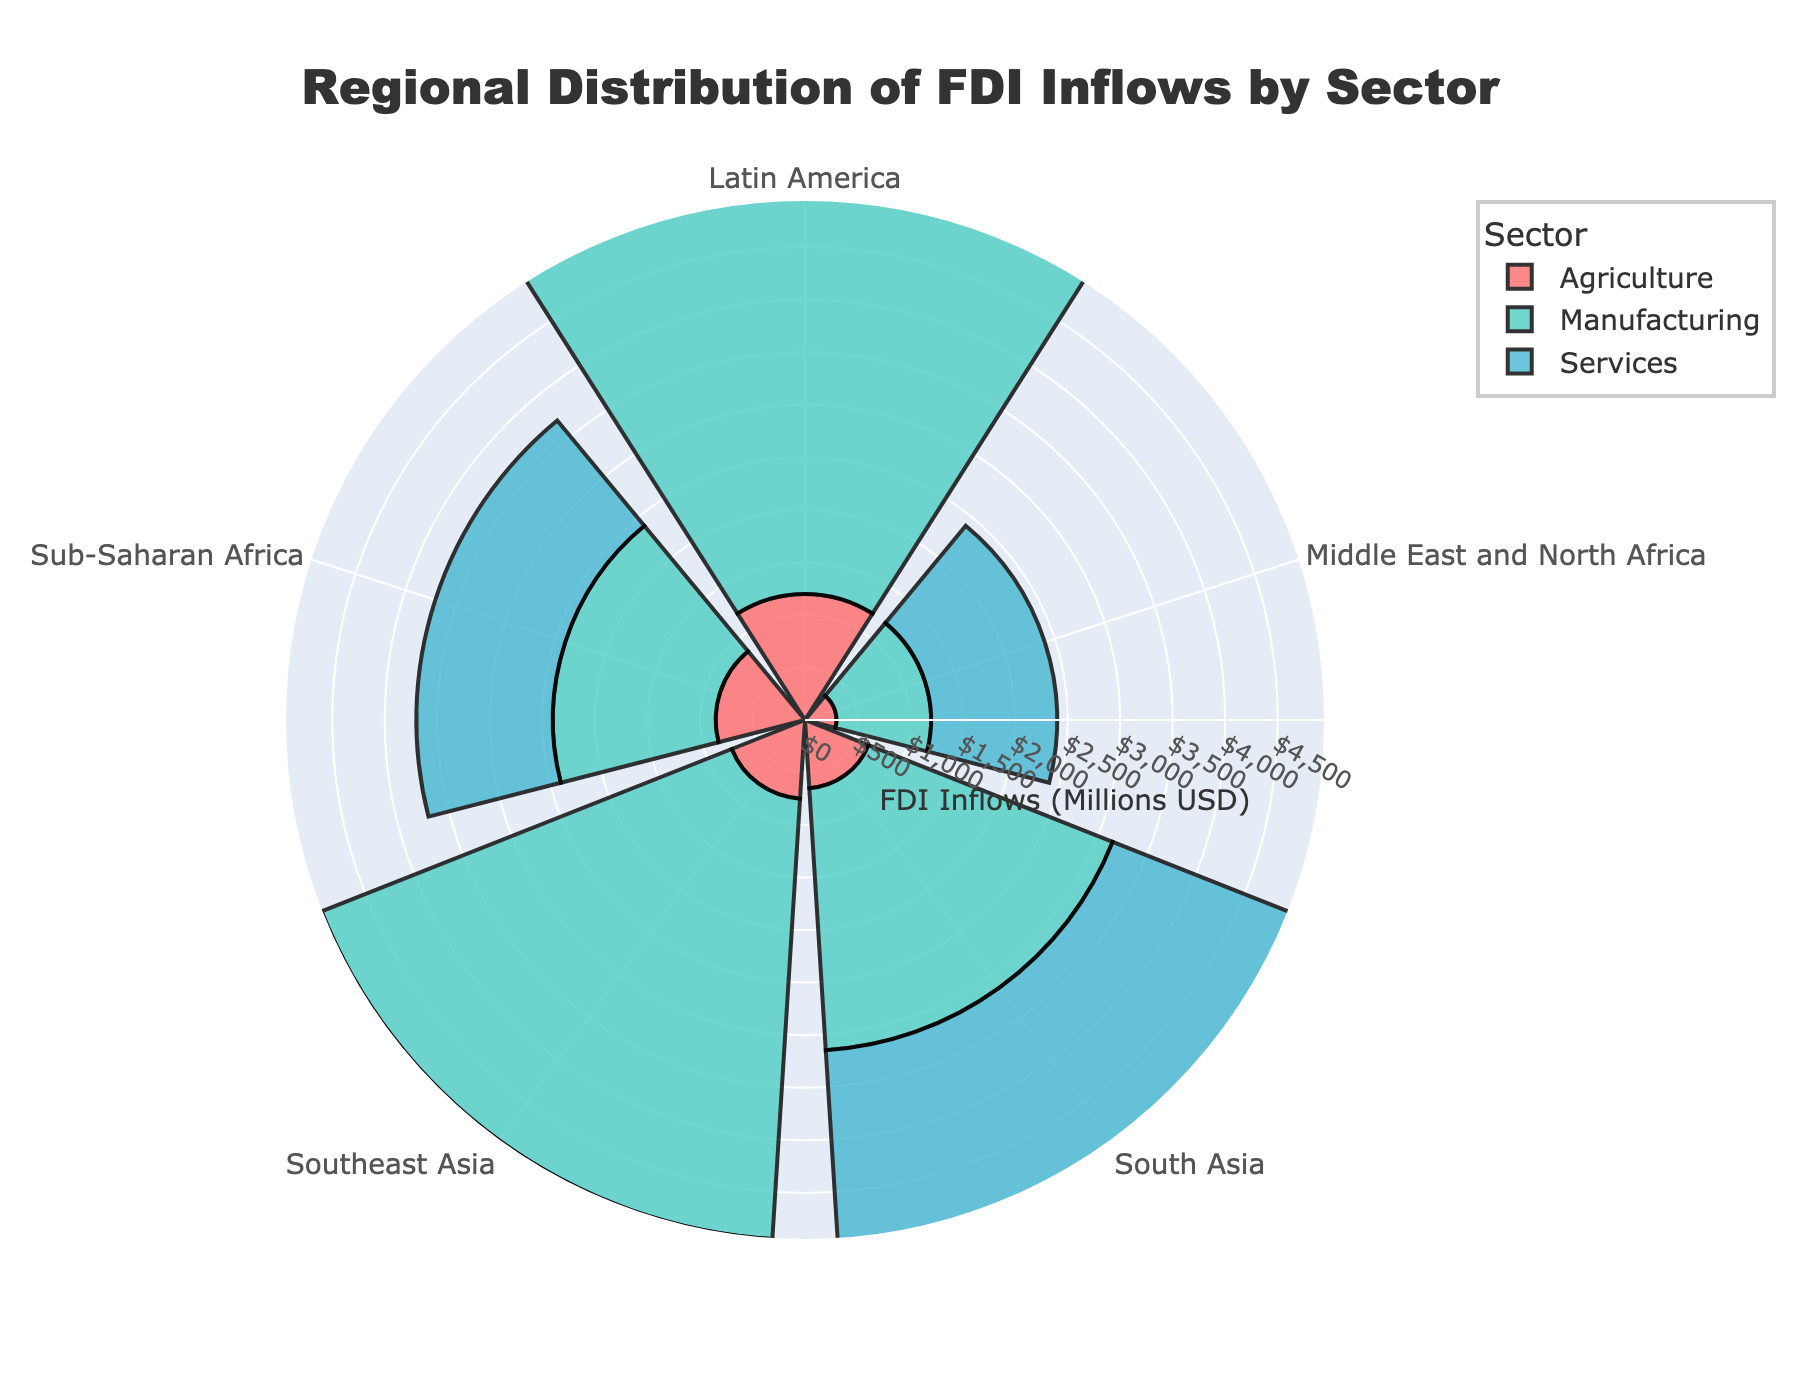What is the title of the rose chart? The title of a rose chart is typically located at the top of the figure and describes what the chart represents. In this case, the title states "Regional Distribution of FDI Inflows by Sector".
Answer: Regional Distribution of FDI Inflows by Sector How many sectors are represented in the rose chart? By observing the legend or the categorical divisions in the chart, one can see there are three sectors: Agriculture, Manufacturing, and Services.
Answer: Three Which sector received the highest FDI inflows in Southeast Asia? To answer this, look at the lengths of the sectors' bars in the section labeled "Southeast Asia". The sector with the highest value will have the longest bar. In this case, the Services sector has the longest bar.
Answer: Services Which region received the least FDI inflows in Agriculture? Check each bar segment representing Agriculture across all regions. The shortest bar corresponds to the region, which is "Middle East and North Africa" in this case.
Answer: Middle East and North Africa What is the total amount of FDI inflows to Sub-Saharan Africa across all sectors? Add the FDI inflows from all sectors for Sub-Saharan Africa: Agriculture (850) + Manufacturing (1550) + Services (1300). The sum is 3700.
Answer: 3700 Which sector has the smallest range of FDI inflows across all regions? Calculate the range (maximum - minimum) for each sector. Agriculture: 1200 - 300 = 900, Manufacturing: 4200 - 900 = 3300, Services: 4500 - 1200 = 3300. Agriculture has the smallest range.
Answer: Agriculture How does the FDI inflow into Services compare between Latin America and South Asia? Compare the lengths of the Services bars for Latin America and South Asia. Latin America has an inflow of 4500, and South Asia has an inflow of 2100. The FDI inflow into Services is higher in Latin America.
Answer: Latin America has higher inflows What's the average FDI inflow into Manufacturing across all regions? Sum the FDI inflows in Manufacturing for all regions and divide by the number of regions. (1550 + 2500 + 4200 + 3800 + 900) / 5 = 12950 / 5 = 2590
Answer: 2590 Which region has the most balanced distribution of FDI inflows across the three sectors? Calculate the variance or visually inspect the balance in the lengths of the bars for each sector within a region. Sub-Saharan Africa appears to have relatively balanced bars for Agriculture (850), Manufacturing (1550), and Services (1300).
Answer: Sub-Saharan Africa Which region has the widest distribution of FDI inflows? To find the region with the widest distribution, subtract the smallest sector inflow from the largest sector inflow in each region. The widest difference indicates the widest distribution. For example:
 - Sub-Saharan Africa: 1550 - 850 = 700,
 - South Asia: 2500 - 650 = 1850,
 - Southeast Asia: 4200 - 750 = 3450,
 - Latin America: 4500 - 1200 = 3300,
 - Middle East and North Africa: 1200 - 300 = 900.
 Southeast Asia has the widest distribution with a difference of 3450.
Answer: Southeast Asia 